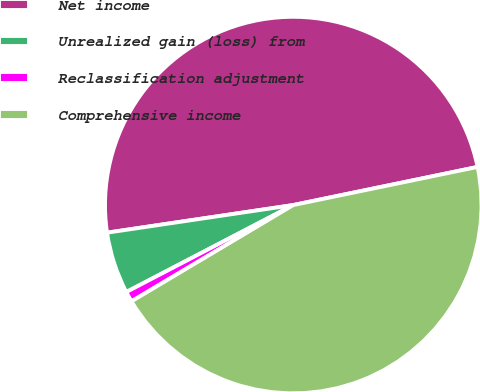Convert chart to OTSL. <chart><loc_0><loc_0><loc_500><loc_500><pie_chart><fcel>Net income<fcel>Unrealized gain (loss) from<fcel>Reclassification adjustment<fcel>Comprehensive income<nl><fcel>49.1%<fcel>5.3%<fcel>0.9%<fcel>44.7%<nl></chart> 